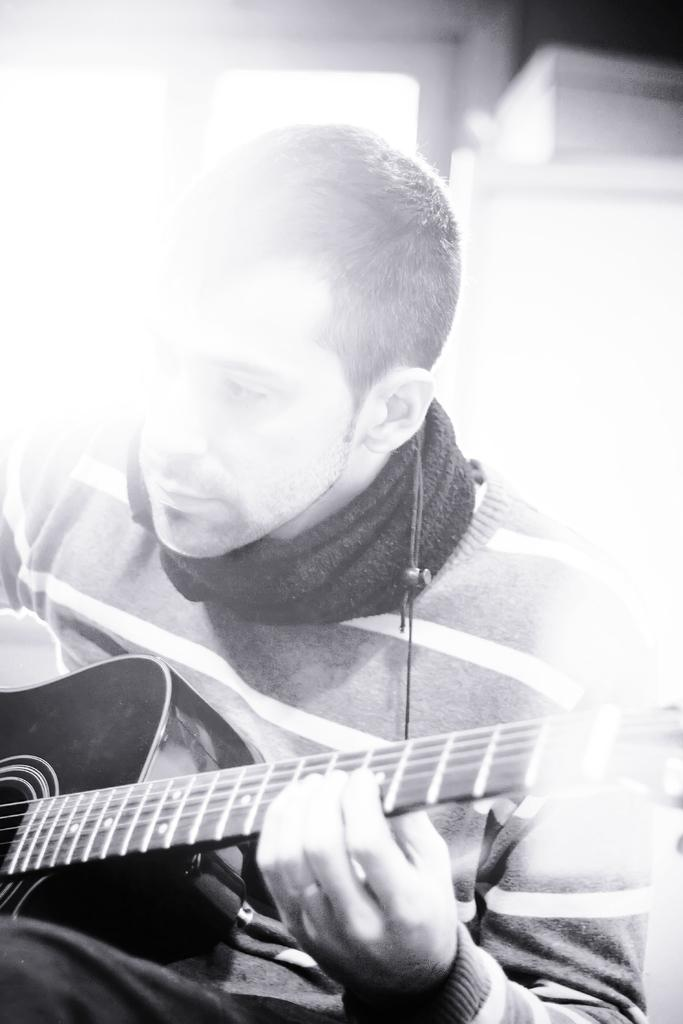What is the main subject of the image? There is a man in the image. What is the man holding in the image? The man is holding a guitar. What type of pickle is on the shelf behind the man in the image? There is no shelf or pickle present in the image; it only features a man holding a guitar. 